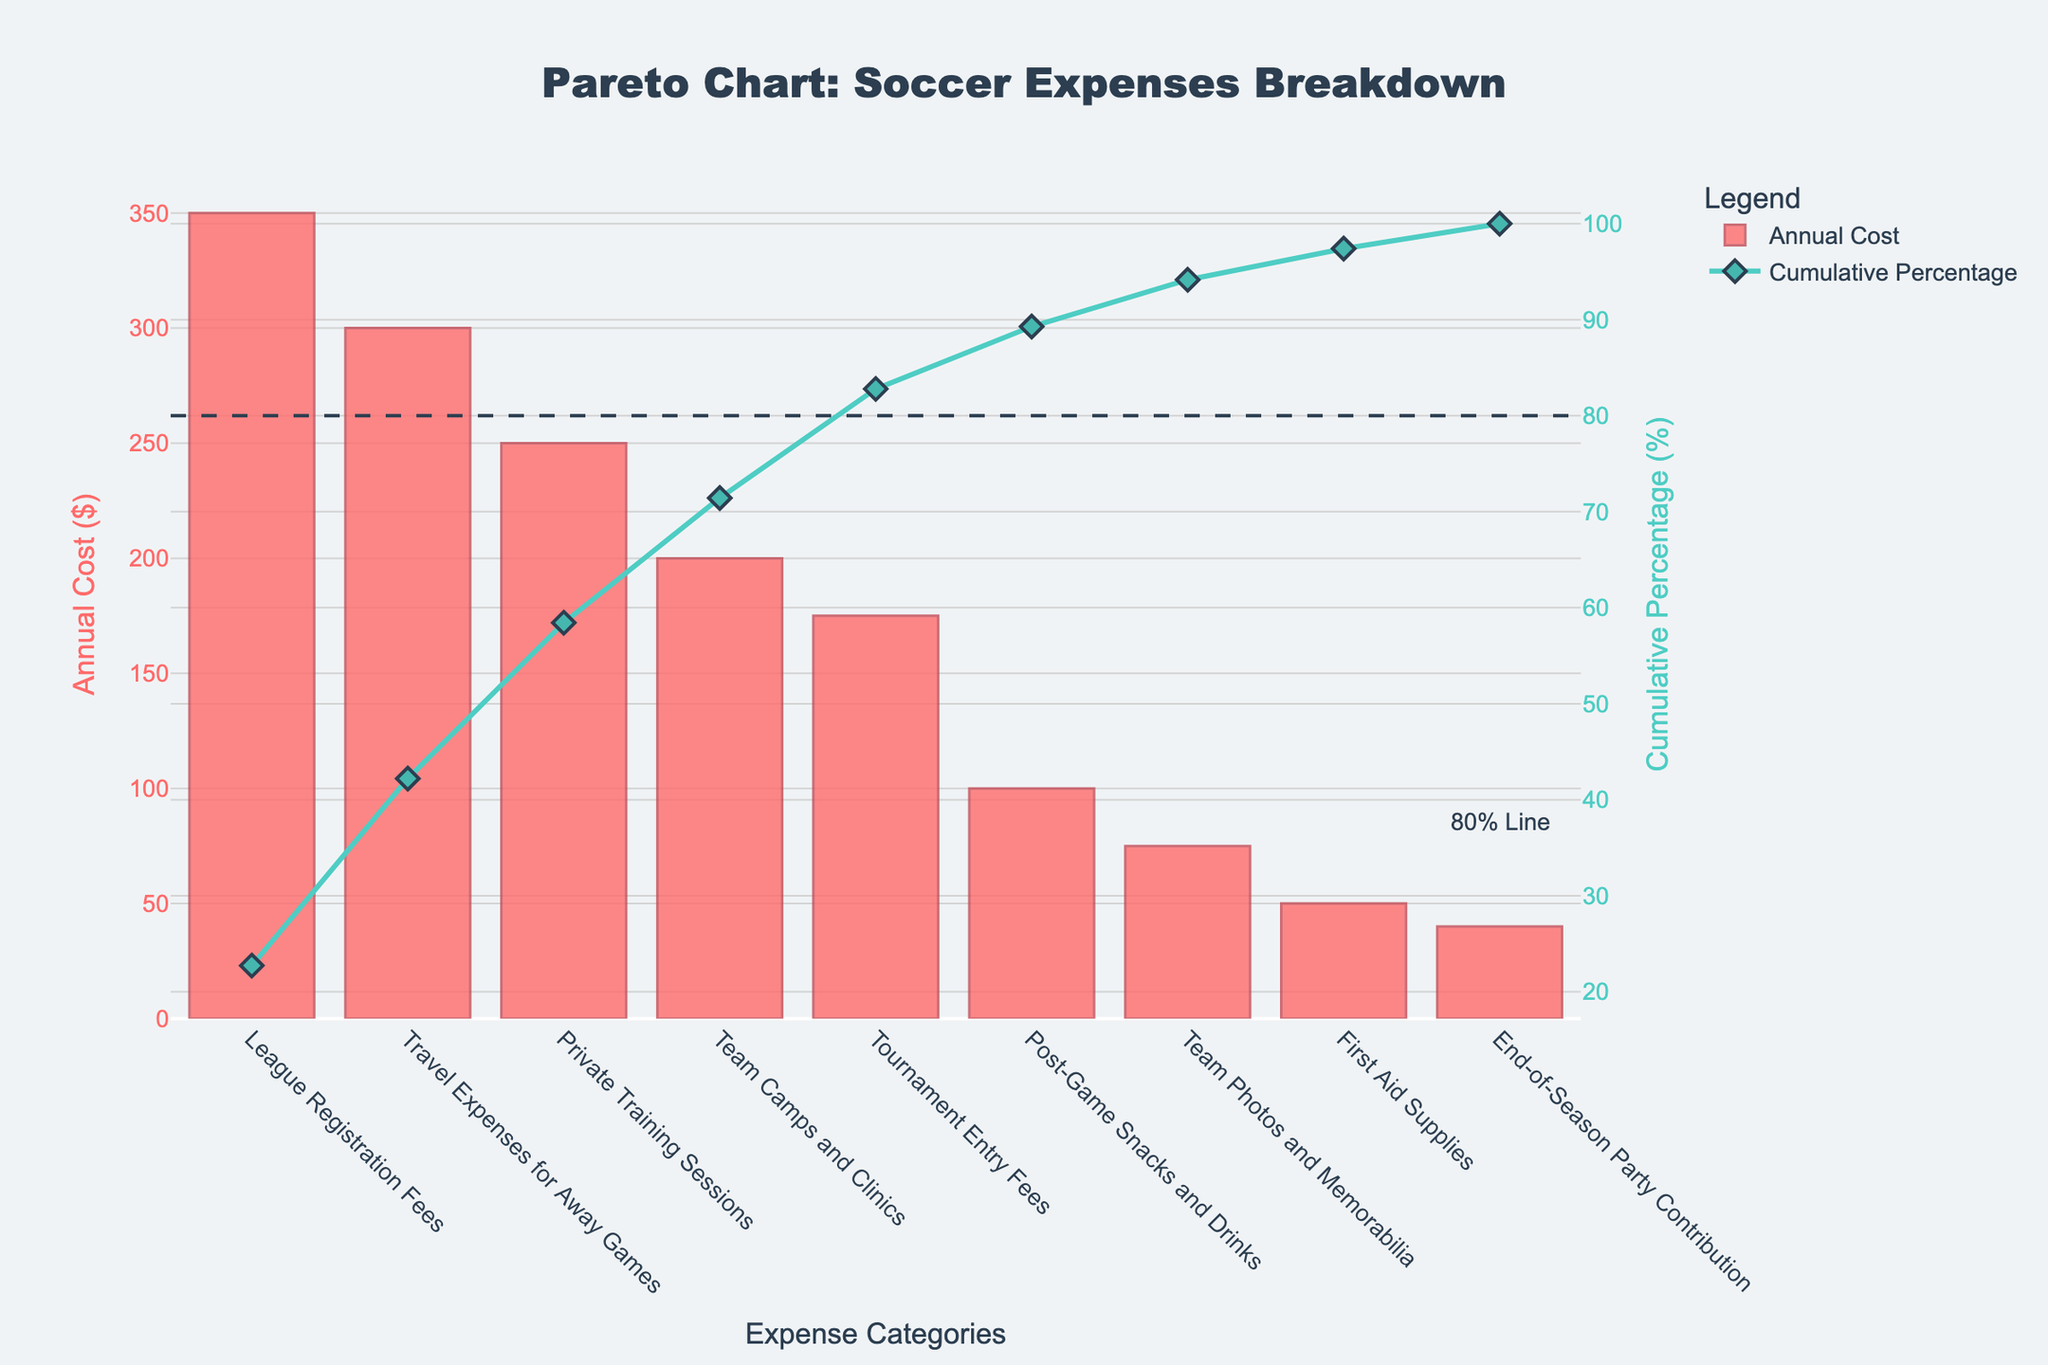What's the highest annual cost category? The highest annual cost category can be identified by looking at the tallest bar in the bar chart.
Answer: League Registration Fees What is the cumulative percentage after including the first three categories? To find the cumulative percentage after the first three categories, look where the line chart for cumulative percentage intersects above the third bar. The first three categories are: League Registration Fees, Travel Expenses for Away Games, and Private Training Sessions.
Answer: 65% How much more do League Registration Fees cost compared to the End-of-Season Party Contribution? To find the cost difference, subtract the cost of the End-of-Season Party Contribution from the cost of League Registration Fees. League Registration Fees cost $350 and End-of-Season Party Contribution costs $40.
Answer: $310 Which category crosses the 80% cumulative percentage line? The category that crosses the 80% cumulative percentage line can be identified by finding where the cumulative percentage line intersects with the 80% reference line.
Answer: Tournament Entry Fees What is the total cost of the categories that make up the first 80% of expenses? To find the total cost, add the annual costs of the categories until the cumulative percentage crosses 80%. These categories are: League Registration Fees, Travel Expenses for Away Games, Private Training Sessions, Team Camps and Clinics, and Tournament Entry Fees ($350 + $300 + $250 + $200 + $175).
Answer: $1,275 How many categories are listed in the Pareto chart? To find the total number of categories, count the number of bars in the bar chart.
Answer: 9 Which expense category has the lowest annual cost? The lowest annual cost category can be identified by looking at the shortest bar in the bar chart.
Answer: End-of-Season Party Contribution By what percentage does the cumulative percentage increase after adding Private Training Sessions to League Registration Fees and Travel Expenses for Away Games? To find the percentage increase, subtract the cumulative percentage after the first three categories from the cumulative percentage after the first two categories. The cumulative percentage after the first two categories (League Registration Fees and Travel Expenses for Away Games) is 54%; after adding Private Training Sessions, it is 65%. So, 65% - 54% = 11%.
Answer: 11% What is the combined annual cost for Post-Game Snacks and Drinks and Team Photos and Memorabilia? To find the combined cost, add the annual costs of Post-Game Snacks and Drinks ($100) and Team Photos and Memorabilia ($75).
Answer: $175 Which category's annual cost is closest to the average annual cost of all categories? To find the average annual cost, first, calculate the total cost of all categories and then divide by the number of categories. The total cost is $1,540 for 9 categories. The average cost is $1,540 / 9 ≈ $171.11. The category closest to this amount is Tournament Entry Fees with a cost of $175.
Answer: Tournament Entry Fees 